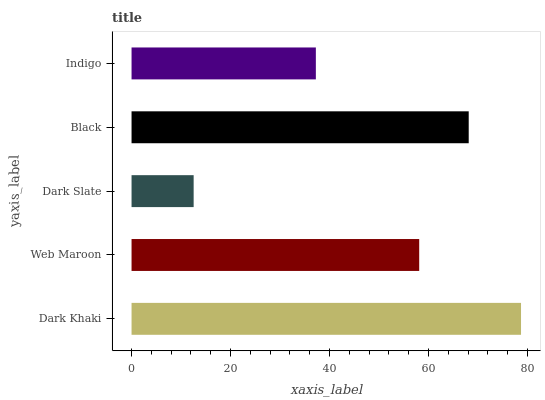Is Dark Slate the minimum?
Answer yes or no. Yes. Is Dark Khaki the maximum?
Answer yes or no. Yes. Is Web Maroon the minimum?
Answer yes or no. No. Is Web Maroon the maximum?
Answer yes or no. No. Is Dark Khaki greater than Web Maroon?
Answer yes or no. Yes. Is Web Maroon less than Dark Khaki?
Answer yes or no. Yes. Is Web Maroon greater than Dark Khaki?
Answer yes or no. No. Is Dark Khaki less than Web Maroon?
Answer yes or no. No. Is Web Maroon the high median?
Answer yes or no. Yes. Is Web Maroon the low median?
Answer yes or no. Yes. Is Dark Khaki the high median?
Answer yes or no. No. Is Black the low median?
Answer yes or no. No. 